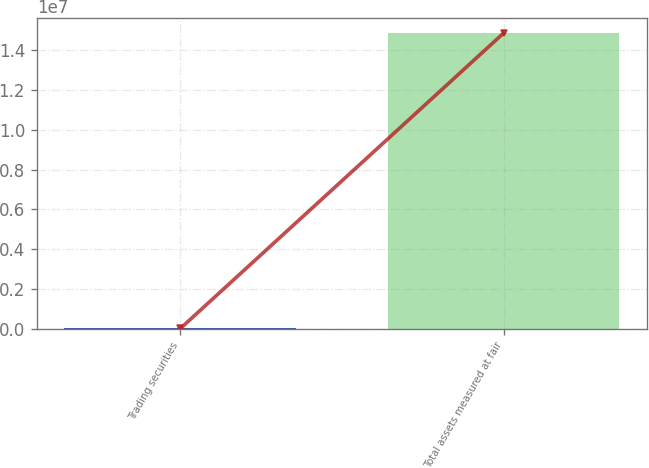<chart> <loc_0><loc_0><loc_500><loc_500><bar_chart><fcel>Trading securities<fcel>Total assets measured at fair<nl><fcel>5913<fcel>1.48653e+07<nl></chart> 